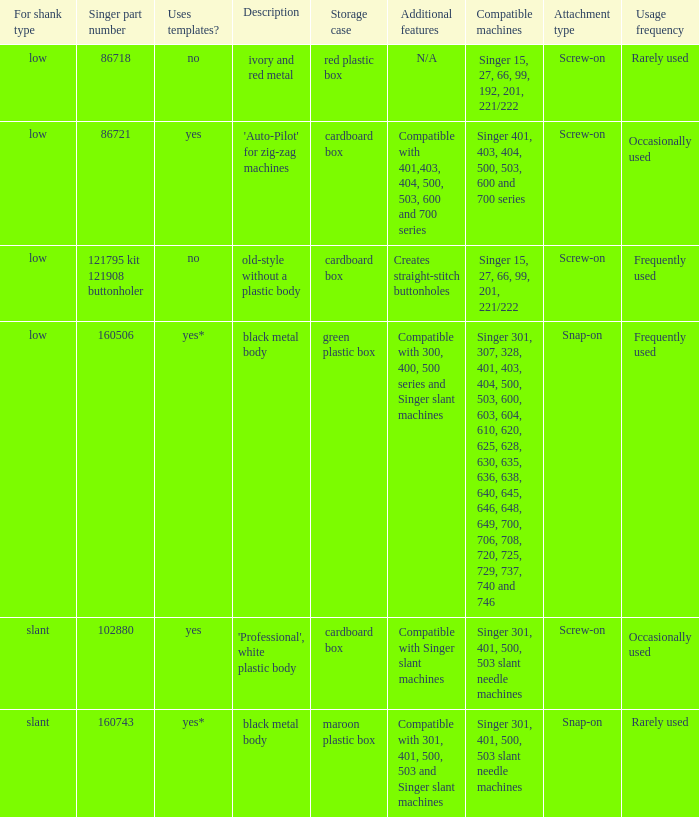What's the singer part number of the buttonholer whose storage case is a green plastic box? 160506.0. 